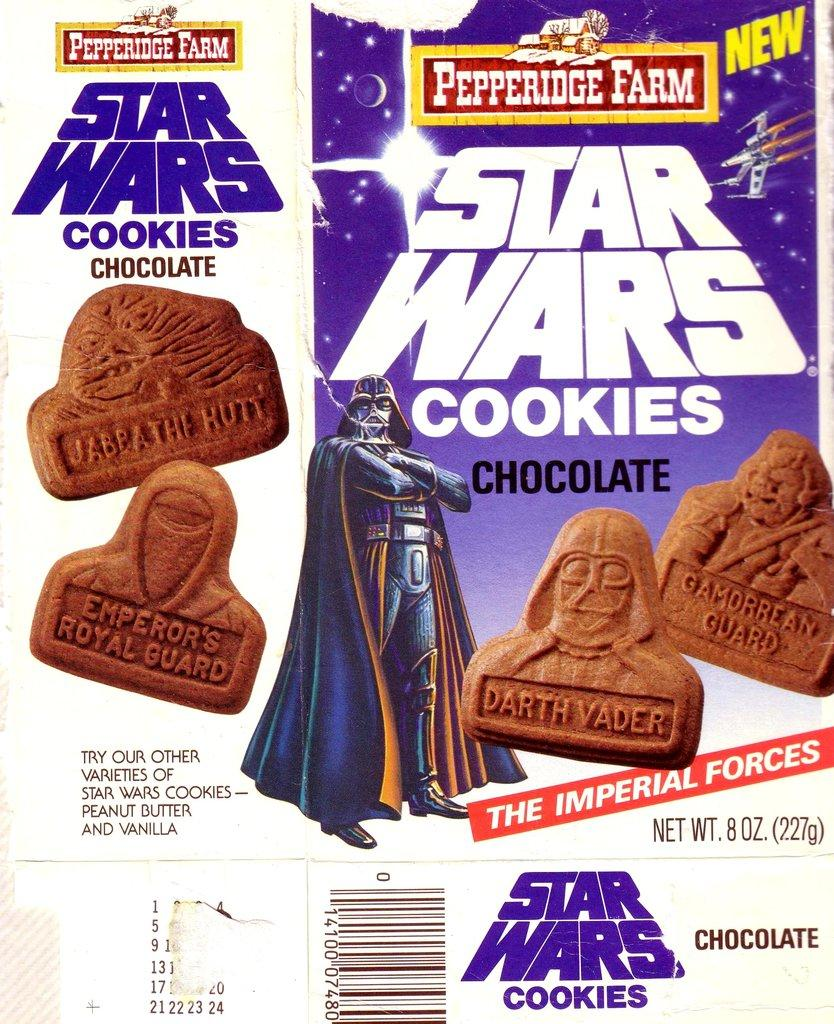What is present in the image? There is a paper in the image. What can be seen on the paper? The paper has images of cookies in brown color. What type of jeans are visible in the image? There are no jeans present in the image; it only features a paper with images of cookies. Can you see a cup in the image? There is no cup visible in the image; it only contains a paper with images of cookies. 